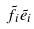<formula> <loc_0><loc_0><loc_500><loc_500>\tilde { f } _ { i } \tilde { e } _ { i }</formula> 